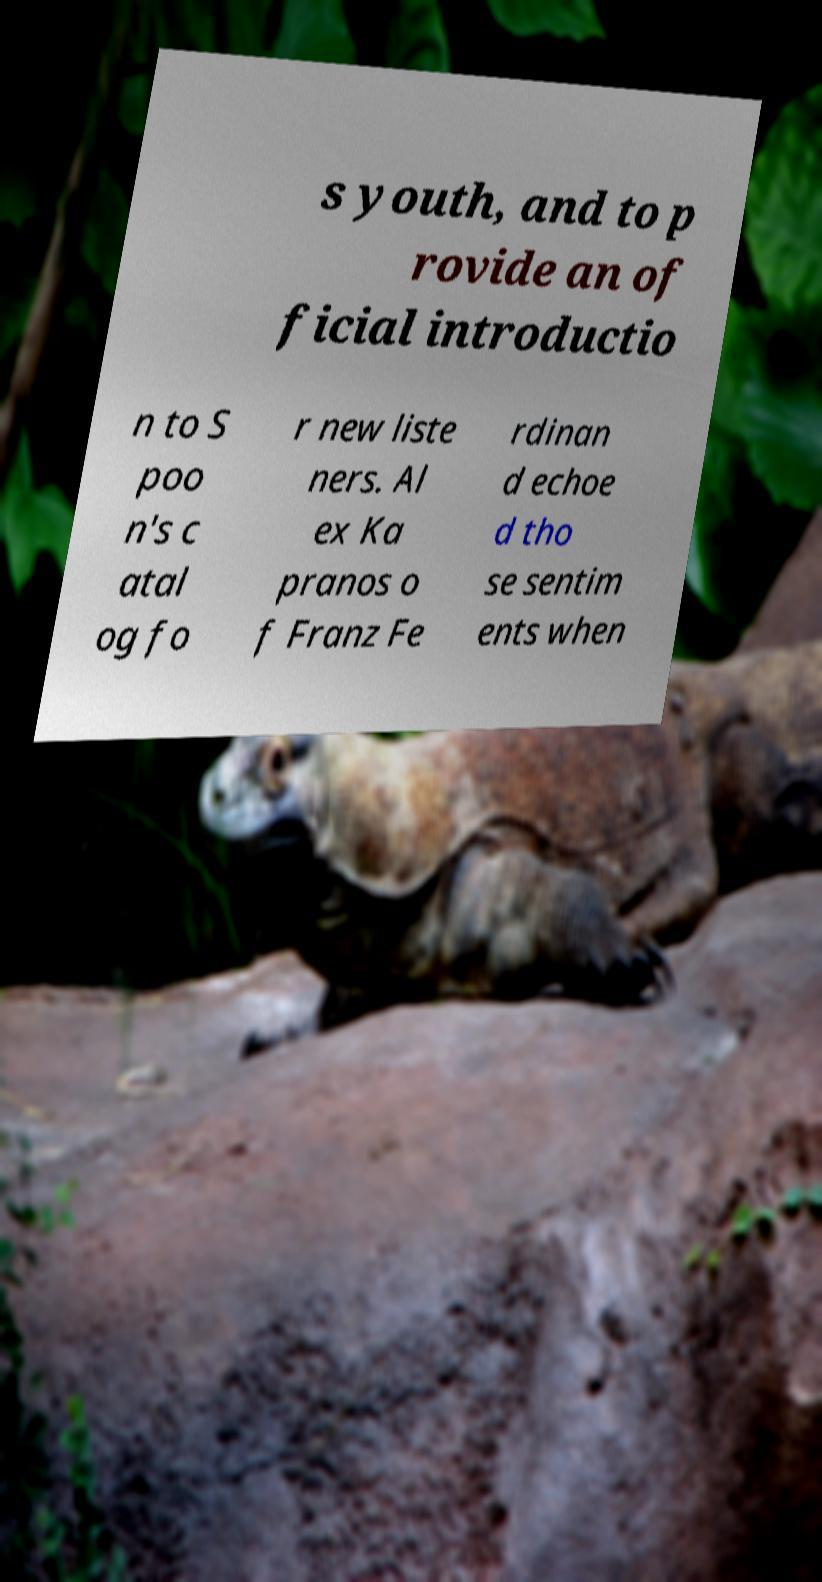There's text embedded in this image that I need extracted. Can you transcribe it verbatim? s youth, and to p rovide an of ficial introductio n to S poo n's c atal og fo r new liste ners. Al ex Ka pranos o f Franz Fe rdinan d echoe d tho se sentim ents when 